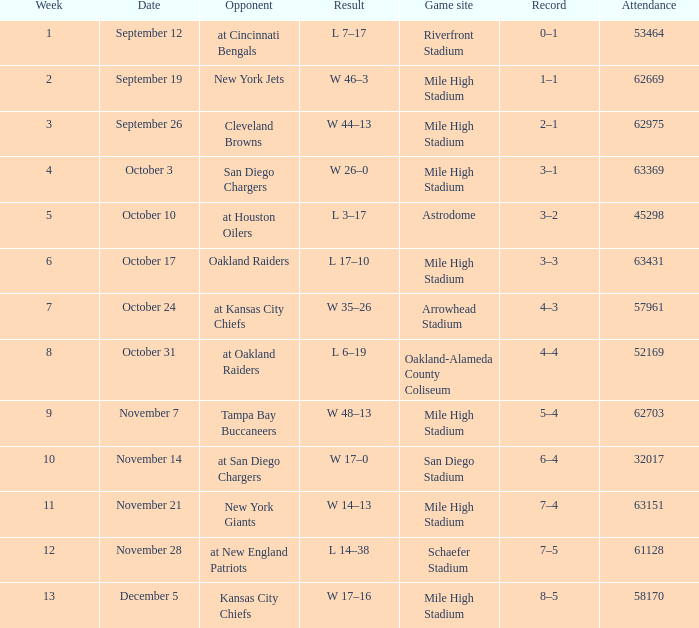What was the week number when the opponent was the New York Jets? 2.0. 